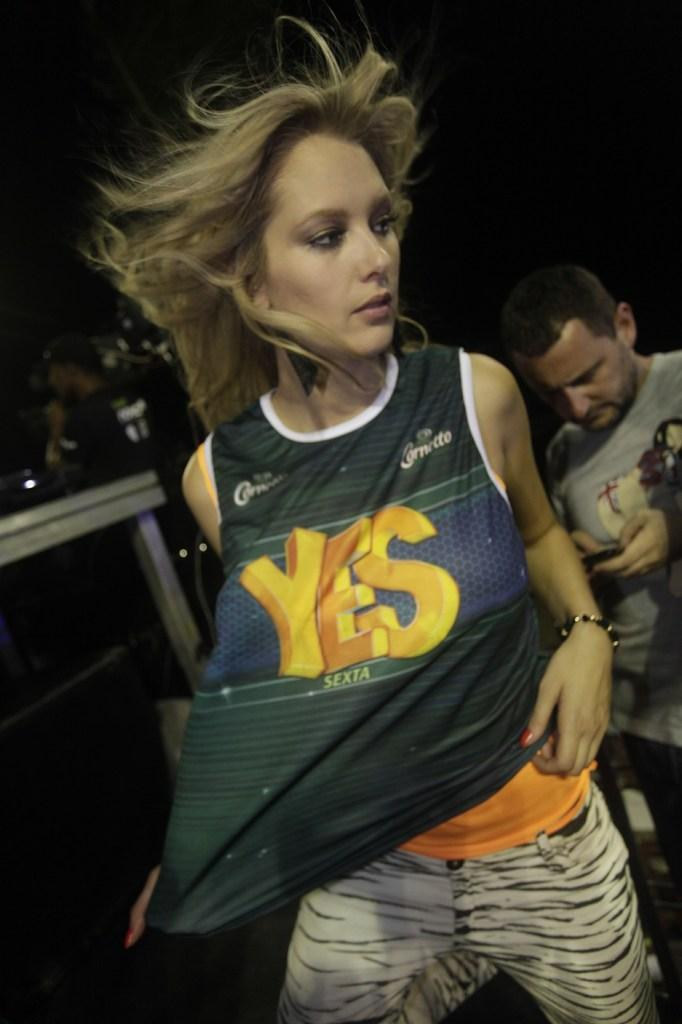Who is the main subject in the foreground of the image? There is a woman in the foreground of the image. What can be seen in the background of the image? There is a man in the background of the image, and he is holding a mobile. What else is visible in the background of the image? There are objects visible in the background of the image. What type of street can be seen in the image? There is no street visible in the image. 